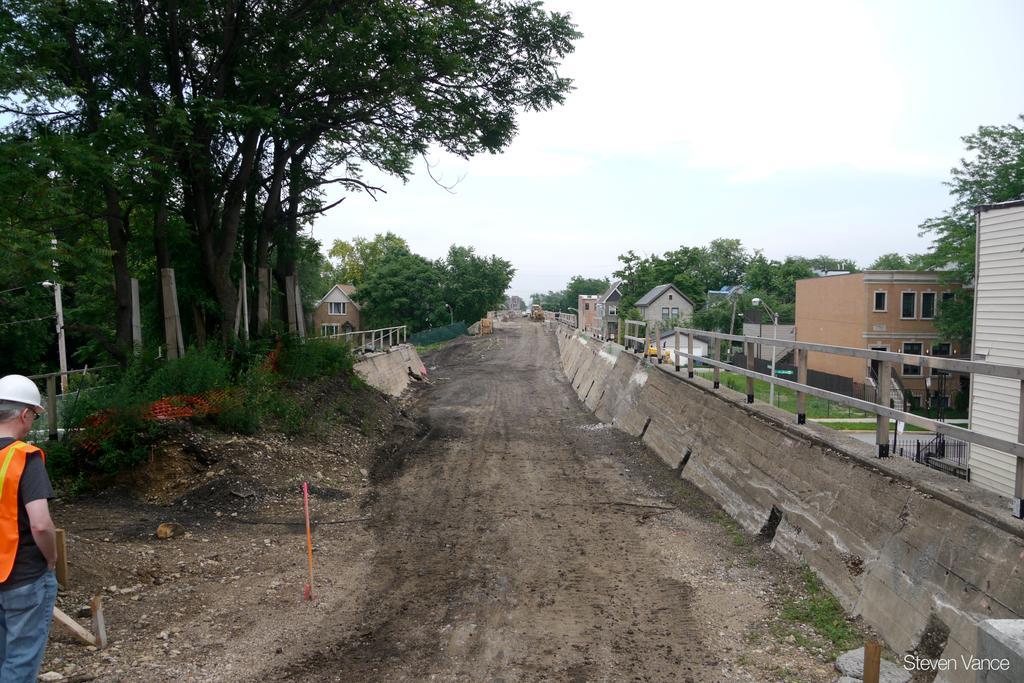Can you describe this image briefly? In this image in the front there is a person standing. In the background there are trees and there are houses, there are railings and the sky is cloudy and there is grass on the ground. On the bottom right of the image there is some text which is visible. 